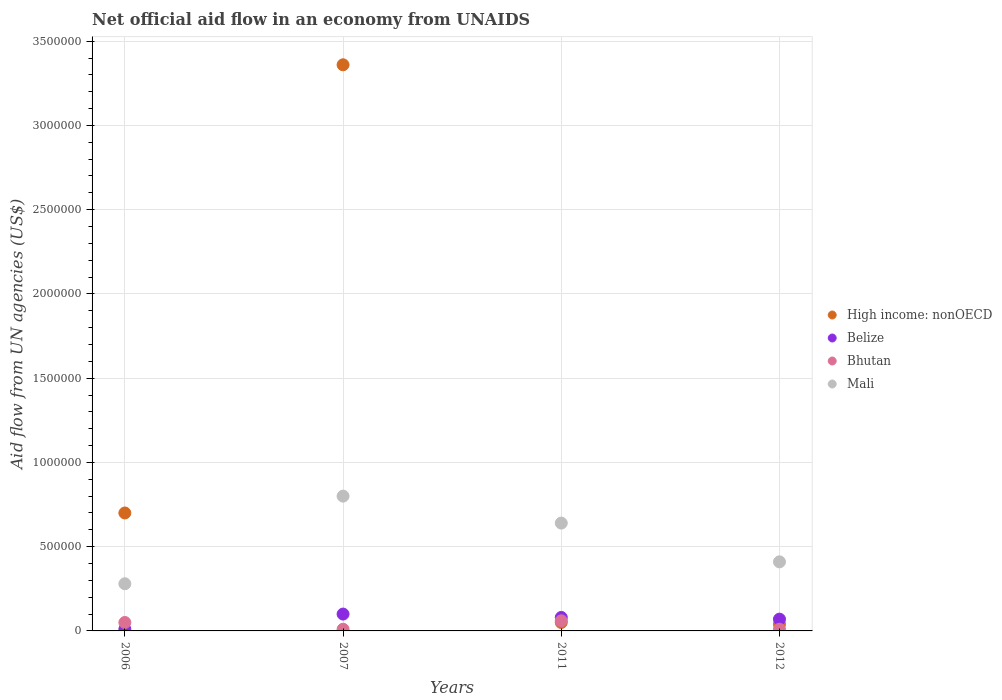Across all years, what is the minimum net official aid flow in Bhutan?
Ensure brevity in your answer.  10000. In which year was the net official aid flow in Mali maximum?
Your response must be concise. 2007. What is the total net official aid flow in Mali in the graph?
Give a very brief answer. 2.13e+06. What is the difference between the net official aid flow in Belize in 2007 and that in 2012?
Provide a short and direct response. 3.00e+04. What is the average net official aid flow in High income: nonOECD per year?
Offer a terse response. 1.04e+06. In how many years, is the net official aid flow in Belize greater than 2600000 US$?
Give a very brief answer. 0. What is the ratio of the net official aid flow in Belize in 2007 to that in 2012?
Offer a very short reply. 1.43. Is the net official aid flow in Mali in 2007 less than that in 2012?
Your response must be concise. No. What is the difference between the highest and the lowest net official aid flow in Mali?
Offer a very short reply. 5.20e+05. In how many years, is the net official aid flow in High income: nonOECD greater than the average net official aid flow in High income: nonOECD taken over all years?
Offer a very short reply. 1. Is the sum of the net official aid flow in Belize in 2007 and 2012 greater than the maximum net official aid flow in Mali across all years?
Ensure brevity in your answer.  No. Is it the case that in every year, the sum of the net official aid flow in Bhutan and net official aid flow in Mali  is greater than the sum of net official aid flow in High income: nonOECD and net official aid flow in Belize?
Ensure brevity in your answer.  Yes. Is it the case that in every year, the sum of the net official aid flow in High income: nonOECD and net official aid flow in Mali  is greater than the net official aid flow in Belize?
Provide a succinct answer. Yes. Does the net official aid flow in Bhutan monotonically increase over the years?
Your answer should be compact. No. Is the net official aid flow in High income: nonOECD strictly greater than the net official aid flow in Bhutan over the years?
Your answer should be very brief. No. Is the net official aid flow in Belize strictly less than the net official aid flow in Bhutan over the years?
Ensure brevity in your answer.  No. What is the difference between two consecutive major ticks on the Y-axis?
Provide a short and direct response. 5.00e+05. Does the graph contain any zero values?
Make the answer very short. No. Does the graph contain grids?
Your answer should be compact. Yes. What is the title of the graph?
Keep it short and to the point. Net official aid flow in an economy from UNAIDS. Does "Cuba" appear as one of the legend labels in the graph?
Provide a short and direct response. No. What is the label or title of the X-axis?
Your answer should be very brief. Years. What is the label or title of the Y-axis?
Provide a succinct answer. Aid flow from UN agencies (US$). What is the Aid flow from UN agencies (US$) in High income: nonOECD in 2007?
Provide a short and direct response. 3.36e+06. What is the Aid flow from UN agencies (US$) of Belize in 2007?
Offer a terse response. 1.00e+05. What is the Aid flow from UN agencies (US$) in Mali in 2007?
Offer a terse response. 8.00e+05. What is the Aid flow from UN agencies (US$) of High income: nonOECD in 2011?
Keep it short and to the point. 5.00e+04. What is the Aid flow from UN agencies (US$) of Belize in 2011?
Give a very brief answer. 8.00e+04. What is the Aid flow from UN agencies (US$) in Bhutan in 2011?
Your answer should be very brief. 6.00e+04. What is the Aid flow from UN agencies (US$) in Mali in 2011?
Ensure brevity in your answer.  6.40e+05. What is the Aid flow from UN agencies (US$) in High income: nonOECD in 2012?
Ensure brevity in your answer.  4.00e+04. What is the Aid flow from UN agencies (US$) of Mali in 2012?
Offer a terse response. 4.10e+05. Across all years, what is the maximum Aid flow from UN agencies (US$) of High income: nonOECD?
Your answer should be very brief. 3.36e+06. Across all years, what is the minimum Aid flow from UN agencies (US$) in Belize?
Offer a very short reply. 10000. Across all years, what is the minimum Aid flow from UN agencies (US$) in Mali?
Ensure brevity in your answer.  2.80e+05. What is the total Aid flow from UN agencies (US$) of High income: nonOECD in the graph?
Keep it short and to the point. 4.15e+06. What is the total Aid flow from UN agencies (US$) in Mali in the graph?
Give a very brief answer. 2.13e+06. What is the difference between the Aid flow from UN agencies (US$) in High income: nonOECD in 2006 and that in 2007?
Offer a terse response. -2.66e+06. What is the difference between the Aid flow from UN agencies (US$) in Belize in 2006 and that in 2007?
Your response must be concise. -9.00e+04. What is the difference between the Aid flow from UN agencies (US$) in Mali in 2006 and that in 2007?
Your answer should be very brief. -5.20e+05. What is the difference between the Aid flow from UN agencies (US$) of High income: nonOECD in 2006 and that in 2011?
Your response must be concise. 6.50e+05. What is the difference between the Aid flow from UN agencies (US$) of Belize in 2006 and that in 2011?
Give a very brief answer. -7.00e+04. What is the difference between the Aid flow from UN agencies (US$) of Mali in 2006 and that in 2011?
Your answer should be very brief. -3.60e+05. What is the difference between the Aid flow from UN agencies (US$) of High income: nonOECD in 2006 and that in 2012?
Give a very brief answer. 6.60e+05. What is the difference between the Aid flow from UN agencies (US$) of Belize in 2006 and that in 2012?
Provide a succinct answer. -6.00e+04. What is the difference between the Aid flow from UN agencies (US$) in Bhutan in 2006 and that in 2012?
Offer a terse response. 4.00e+04. What is the difference between the Aid flow from UN agencies (US$) of High income: nonOECD in 2007 and that in 2011?
Your response must be concise. 3.31e+06. What is the difference between the Aid flow from UN agencies (US$) in High income: nonOECD in 2007 and that in 2012?
Your answer should be compact. 3.32e+06. What is the difference between the Aid flow from UN agencies (US$) of Belize in 2007 and that in 2012?
Keep it short and to the point. 3.00e+04. What is the difference between the Aid flow from UN agencies (US$) in Bhutan in 2007 and that in 2012?
Keep it short and to the point. 0. What is the difference between the Aid flow from UN agencies (US$) of Bhutan in 2011 and that in 2012?
Keep it short and to the point. 5.00e+04. What is the difference between the Aid flow from UN agencies (US$) in Mali in 2011 and that in 2012?
Offer a very short reply. 2.30e+05. What is the difference between the Aid flow from UN agencies (US$) in High income: nonOECD in 2006 and the Aid flow from UN agencies (US$) in Belize in 2007?
Provide a short and direct response. 6.00e+05. What is the difference between the Aid flow from UN agencies (US$) of High income: nonOECD in 2006 and the Aid flow from UN agencies (US$) of Bhutan in 2007?
Give a very brief answer. 6.90e+05. What is the difference between the Aid flow from UN agencies (US$) in High income: nonOECD in 2006 and the Aid flow from UN agencies (US$) in Mali in 2007?
Make the answer very short. -1.00e+05. What is the difference between the Aid flow from UN agencies (US$) in Belize in 2006 and the Aid flow from UN agencies (US$) in Bhutan in 2007?
Keep it short and to the point. 0. What is the difference between the Aid flow from UN agencies (US$) in Belize in 2006 and the Aid flow from UN agencies (US$) in Mali in 2007?
Make the answer very short. -7.90e+05. What is the difference between the Aid flow from UN agencies (US$) in Bhutan in 2006 and the Aid flow from UN agencies (US$) in Mali in 2007?
Provide a succinct answer. -7.50e+05. What is the difference between the Aid flow from UN agencies (US$) of High income: nonOECD in 2006 and the Aid flow from UN agencies (US$) of Belize in 2011?
Offer a very short reply. 6.20e+05. What is the difference between the Aid flow from UN agencies (US$) in High income: nonOECD in 2006 and the Aid flow from UN agencies (US$) in Bhutan in 2011?
Give a very brief answer. 6.40e+05. What is the difference between the Aid flow from UN agencies (US$) in High income: nonOECD in 2006 and the Aid flow from UN agencies (US$) in Mali in 2011?
Your response must be concise. 6.00e+04. What is the difference between the Aid flow from UN agencies (US$) of Belize in 2006 and the Aid flow from UN agencies (US$) of Mali in 2011?
Your answer should be compact. -6.30e+05. What is the difference between the Aid flow from UN agencies (US$) in Bhutan in 2006 and the Aid flow from UN agencies (US$) in Mali in 2011?
Your answer should be compact. -5.90e+05. What is the difference between the Aid flow from UN agencies (US$) in High income: nonOECD in 2006 and the Aid flow from UN agencies (US$) in Belize in 2012?
Give a very brief answer. 6.30e+05. What is the difference between the Aid flow from UN agencies (US$) of High income: nonOECD in 2006 and the Aid flow from UN agencies (US$) of Bhutan in 2012?
Offer a very short reply. 6.90e+05. What is the difference between the Aid flow from UN agencies (US$) in High income: nonOECD in 2006 and the Aid flow from UN agencies (US$) in Mali in 2012?
Your response must be concise. 2.90e+05. What is the difference between the Aid flow from UN agencies (US$) of Belize in 2006 and the Aid flow from UN agencies (US$) of Mali in 2012?
Offer a terse response. -4.00e+05. What is the difference between the Aid flow from UN agencies (US$) of Bhutan in 2006 and the Aid flow from UN agencies (US$) of Mali in 2012?
Provide a short and direct response. -3.60e+05. What is the difference between the Aid flow from UN agencies (US$) in High income: nonOECD in 2007 and the Aid flow from UN agencies (US$) in Belize in 2011?
Give a very brief answer. 3.28e+06. What is the difference between the Aid flow from UN agencies (US$) in High income: nonOECD in 2007 and the Aid flow from UN agencies (US$) in Bhutan in 2011?
Keep it short and to the point. 3.30e+06. What is the difference between the Aid flow from UN agencies (US$) in High income: nonOECD in 2007 and the Aid flow from UN agencies (US$) in Mali in 2011?
Your answer should be compact. 2.72e+06. What is the difference between the Aid flow from UN agencies (US$) in Belize in 2007 and the Aid flow from UN agencies (US$) in Mali in 2011?
Your answer should be compact. -5.40e+05. What is the difference between the Aid flow from UN agencies (US$) in Bhutan in 2007 and the Aid flow from UN agencies (US$) in Mali in 2011?
Your answer should be very brief. -6.30e+05. What is the difference between the Aid flow from UN agencies (US$) of High income: nonOECD in 2007 and the Aid flow from UN agencies (US$) of Belize in 2012?
Offer a very short reply. 3.29e+06. What is the difference between the Aid flow from UN agencies (US$) in High income: nonOECD in 2007 and the Aid flow from UN agencies (US$) in Bhutan in 2012?
Keep it short and to the point. 3.35e+06. What is the difference between the Aid flow from UN agencies (US$) in High income: nonOECD in 2007 and the Aid flow from UN agencies (US$) in Mali in 2012?
Make the answer very short. 2.95e+06. What is the difference between the Aid flow from UN agencies (US$) of Belize in 2007 and the Aid flow from UN agencies (US$) of Mali in 2012?
Keep it short and to the point. -3.10e+05. What is the difference between the Aid flow from UN agencies (US$) in Bhutan in 2007 and the Aid flow from UN agencies (US$) in Mali in 2012?
Give a very brief answer. -4.00e+05. What is the difference between the Aid flow from UN agencies (US$) in High income: nonOECD in 2011 and the Aid flow from UN agencies (US$) in Belize in 2012?
Offer a very short reply. -2.00e+04. What is the difference between the Aid flow from UN agencies (US$) of High income: nonOECD in 2011 and the Aid flow from UN agencies (US$) of Mali in 2012?
Make the answer very short. -3.60e+05. What is the difference between the Aid flow from UN agencies (US$) of Belize in 2011 and the Aid flow from UN agencies (US$) of Mali in 2012?
Give a very brief answer. -3.30e+05. What is the difference between the Aid flow from UN agencies (US$) in Bhutan in 2011 and the Aid flow from UN agencies (US$) in Mali in 2012?
Make the answer very short. -3.50e+05. What is the average Aid flow from UN agencies (US$) in High income: nonOECD per year?
Keep it short and to the point. 1.04e+06. What is the average Aid flow from UN agencies (US$) in Belize per year?
Make the answer very short. 6.50e+04. What is the average Aid flow from UN agencies (US$) of Bhutan per year?
Your answer should be compact. 3.25e+04. What is the average Aid flow from UN agencies (US$) of Mali per year?
Your answer should be very brief. 5.32e+05. In the year 2006, what is the difference between the Aid flow from UN agencies (US$) of High income: nonOECD and Aid flow from UN agencies (US$) of Belize?
Offer a terse response. 6.90e+05. In the year 2006, what is the difference between the Aid flow from UN agencies (US$) of High income: nonOECD and Aid flow from UN agencies (US$) of Bhutan?
Provide a short and direct response. 6.50e+05. In the year 2006, what is the difference between the Aid flow from UN agencies (US$) in High income: nonOECD and Aid flow from UN agencies (US$) in Mali?
Provide a succinct answer. 4.20e+05. In the year 2006, what is the difference between the Aid flow from UN agencies (US$) of Belize and Aid flow from UN agencies (US$) of Bhutan?
Offer a very short reply. -4.00e+04. In the year 2006, what is the difference between the Aid flow from UN agencies (US$) of Belize and Aid flow from UN agencies (US$) of Mali?
Make the answer very short. -2.70e+05. In the year 2007, what is the difference between the Aid flow from UN agencies (US$) in High income: nonOECD and Aid flow from UN agencies (US$) in Belize?
Provide a short and direct response. 3.26e+06. In the year 2007, what is the difference between the Aid flow from UN agencies (US$) of High income: nonOECD and Aid flow from UN agencies (US$) of Bhutan?
Your answer should be very brief. 3.35e+06. In the year 2007, what is the difference between the Aid flow from UN agencies (US$) of High income: nonOECD and Aid flow from UN agencies (US$) of Mali?
Offer a very short reply. 2.56e+06. In the year 2007, what is the difference between the Aid flow from UN agencies (US$) in Belize and Aid flow from UN agencies (US$) in Mali?
Your answer should be very brief. -7.00e+05. In the year 2007, what is the difference between the Aid flow from UN agencies (US$) in Bhutan and Aid flow from UN agencies (US$) in Mali?
Offer a terse response. -7.90e+05. In the year 2011, what is the difference between the Aid flow from UN agencies (US$) in High income: nonOECD and Aid flow from UN agencies (US$) in Belize?
Your answer should be compact. -3.00e+04. In the year 2011, what is the difference between the Aid flow from UN agencies (US$) of High income: nonOECD and Aid flow from UN agencies (US$) of Bhutan?
Ensure brevity in your answer.  -10000. In the year 2011, what is the difference between the Aid flow from UN agencies (US$) of High income: nonOECD and Aid flow from UN agencies (US$) of Mali?
Offer a very short reply. -5.90e+05. In the year 2011, what is the difference between the Aid flow from UN agencies (US$) in Belize and Aid flow from UN agencies (US$) in Mali?
Provide a succinct answer. -5.60e+05. In the year 2011, what is the difference between the Aid flow from UN agencies (US$) in Bhutan and Aid flow from UN agencies (US$) in Mali?
Give a very brief answer. -5.80e+05. In the year 2012, what is the difference between the Aid flow from UN agencies (US$) of High income: nonOECD and Aid flow from UN agencies (US$) of Bhutan?
Make the answer very short. 3.00e+04. In the year 2012, what is the difference between the Aid flow from UN agencies (US$) of High income: nonOECD and Aid flow from UN agencies (US$) of Mali?
Your answer should be compact. -3.70e+05. In the year 2012, what is the difference between the Aid flow from UN agencies (US$) of Belize and Aid flow from UN agencies (US$) of Bhutan?
Make the answer very short. 6.00e+04. In the year 2012, what is the difference between the Aid flow from UN agencies (US$) of Belize and Aid flow from UN agencies (US$) of Mali?
Ensure brevity in your answer.  -3.40e+05. In the year 2012, what is the difference between the Aid flow from UN agencies (US$) of Bhutan and Aid flow from UN agencies (US$) of Mali?
Offer a terse response. -4.00e+05. What is the ratio of the Aid flow from UN agencies (US$) of High income: nonOECD in 2006 to that in 2007?
Keep it short and to the point. 0.21. What is the ratio of the Aid flow from UN agencies (US$) of Belize in 2006 to that in 2007?
Provide a short and direct response. 0.1. What is the ratio of the Aid flow from UN agencies (US$) in Bhutan in 2006 to that in 2007?
Make the answer very short. 5. What is the ratio of the Aid flow from UN agencies (US$) of Mali in 2006 to that in 2007?
Give a very brief answer. 0.35. What is the ratio of the Aid flow from UN agencies (US$) in High income: nonOECD in 2006 to that in 2011?
Provide a succinct answer. 14. What is the ratio of the Aid flow from UN agencies (US$) of Bhutan in 2006 to that in 2011?
Give a very brief answer. 0.83. What is the ratio of the Aid flow from UN agencies (US$) of Mali in 2006 to that in 2011?
Provide a succinct answer. 0.44. What is the ratio of the Aid flow from UN agencies (US$) of Belize in 2006 to that in 2012?
Ensure brevity in your answer.  0.14. What is the ratio of the Aid flow from UN agencies (US$) of Bhutan in 2006 to that in 2012?
Keep it short and to the point. 5. What is the ratio of the Aid flow from UN agencies (US$) in Mali in 2006 to that in 2012?
Provide a succinct answer. 0.68. What is the ratio of the Aid flow from UN agencies (US$) of High income: nonOECD in 2007 to that in 2011?
Make the answer very short. 67.2. What is the ratio of the Aid flow from UN agencies (US$) of Belize in 2007 to that in 2011?
Keep it short and to the point. 1.25. What is the ratio of the Aid flow from UN agencies (US$) of Mali in 2007 to that in 2011?
Ensure brevity in your answer.  1.25. What is the ratio of the Aid flow from UN agencies (US$) in High income: nonOECD in 2007 to that in 2012?
Your response must be concise. 84. What is the ratio of the Aid flow from UN agencies (US$) of Belize in 2007 to that in 2012?
Your response must be concise. 1.43. What is the ratio of the Aid flow from UN agencies (US$) of Bhutan in 2007 to that in 2012?
Ensure brevity in your answer.  1. What is the ratio of the Aid flow from UN agencies (US$) of Mali in 2007 to that in 2012?
Your response must be concise. 1.95. What is the ratio of the Aid flow from UN agencies (US$) in Belize in 2011 to that in 2012?
Provide a short and direct response. 1.14. What is the ratio of the Aid flow from UN agencies (US$) of Mali in 2011 to that in 2012?
Your answer should be compact. 1.56. What is the difference between the highest and the second highest Aid flow from UN agencies (US$) of High income: nonOECD?
Provide a succinct answer. 2.66e+06. What is the difference between the highest and the second highest Aid flow from UN agencies (US$) in Belize?
Make the answer very short. 2.00e+04. What is the difference between the highest and the second highest Aid flow from UN agencies (US$) in Bhutan?
Your answer should be very brief. 10000. What is the difference between the highest and the lowest Aid flow from UN agencies (US$) of High income: nonOECD?
Your answer should be very brief. 3.32e+06. What is the difference between the highest and the lowest Aid flow from UN agencies (US$) of Bhutan?
Make the answer very short. 5.00e+04. What is the difference between the highest and the lowest Aid flow from UN agencies (US$) in Mali?
Give a very brief answer. 5.20e+05. 